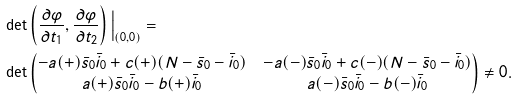<formula> <loc_0><loc_0><loc_500><loc_500>& \det \left ( \frac { \partial \varphi } { \partial t _ { 1 } } , \frac { \partial \varphi } { \partial t _ { 2 } } \right ) \Big | _ { ( 0 , 0 ) } = \\ & \det \begin{pmatrix} - a ( + ) \bar { s } _ { 0 } \bar { i } _ { 0 } + c ( + ) ( N - \bar { s } _ { 0 } - \bar { i } _ { 0 } ) & - a ( - ) \bar { s } _ { 0 } \bar { i } _ { 0 } + c ( - ) ( N - \bar { s } _ { 0 } - \bar { i } _ { 0 } ) \\ a ( + ) \bar { s } _ { 0 } \bar { i } _ { 0 } - b ( + ) \bar { i } _ { 0 } & a ( - ) \bar { s } _ { 0 } \bar { i } _ { 0 } - b ( - ) \bar { i } _ { 0 } \end{pmatrix} \ne 0 .</formula> 